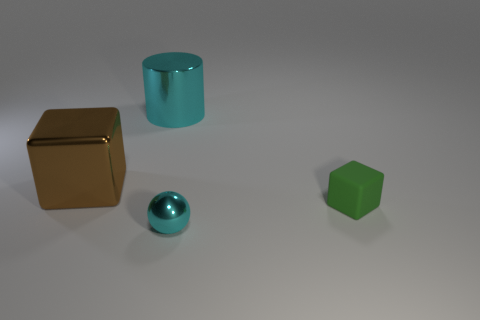What size is the cylinder that is the same material as the brown block?
Keep it short and to the point. Large. What number of matte objects are either brown objects or yellow spheres?
Offer a terse response. 0. How big is the cyan ball?
Offer a very short reply. Small. Do the brown cube and the green object have the same size?
Provide a succinct answer. No. There is a cyan thing that is behind the small ball; what is it made of?
Provide a short and direct response. Metal. There is another object that is the same shape as the small rubber thing; what is it made of?
Provide a short and direct response. Metal. Is there a cyan cylinder that is on the right side of the object right of the cyan metal ball?
Offer a terse response. No. Does the tiny green thing have the same shape as the big brown thing?
Keep it short and to the point. Yes. There is a large cyan object that is the same material as the small cyan thing; what is its shape?
Offer a very short reply. Cylinder. Does the cyan metallic thing behind the small cyan shiny sphere have the same size as the cyan ball in front of the large cyan cylinder?
Make the answer very short. No. 